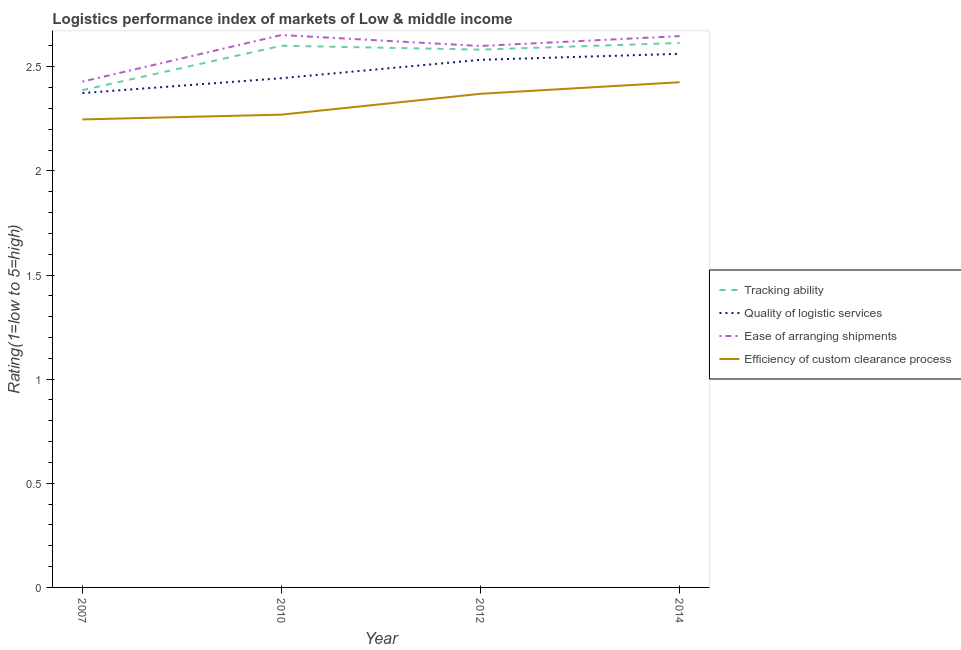Is the number of lines equal to the number of legend labels?
Provide a succinct answer. Yes. What is the lpi rating of efficiency of custom clearance process in 2007?
Provide a succinct answer. 2.25. Across all years, what is the maximum lpi rating of ease of arranging shipments?
Your response must be concise. 2.65. Across all years, what is the minimum lpi rating of quality of logistic services?
Ensure brevity in your answer.  2.37. In which year was the lpi rating of quality of logistic services maximum?
Your answer should be very brief. 2014. In which year was the lpi rating of efficiency of custom clearance process minimum?
Make the answer very short. 2007. What is the total lpi rating of tracking ability in the graph?
Your answer should be very brief. 10.19. What is the difference between the lpi rating of tracking ability in 2007 and that in 2010?
Your answer should be compact. -0.21. What is the difference between the lpi rating of tracking ability in 2012 and the lpi rating of quality of logistic services in 2007?
Provide a succinct answer. 0.21. What is the average lpi rating of efficiency of custom clearance process per year?
Ensure brevity in your answer.  2.33. In the year 2014, what is the difference between the lpi rating of quality of logistic services and lpi rating of efficiency of custom clearance process?
Offer a terse response. 0.14. What is the ratio of the lpi rating of quality of logistic services in 2010 to that in 2012?
Provide a succinct answer. 0.97. What is the difference between the highest and the second highest lpi rating of ease of arranging shipments?
Give a very brief answer. 0.01. What is the difference between the highest and the lowest lpi rating of ease of arranging shipments?
Keep it short and to the point. 0.22. Is the sum of the lpi rating of tracking ability in 2012 and 2014 greater than the maximum lpi rating of efficiency of custom clearance process across all years?
Make the answer very short. Yes. Is the lpi rating of ease of arranging shipments strictly greater than the lpi rating of tracking ability over the years?
Your answer should be compact. Yes. Are the values on the major ticks of Y-axis written in scientific E-notation?
Your answer should be very brief. No. Where does the legend appear in the graph?
Make the answer very short. Center right. What is the title of the graph?
Your answer should be compact. Logistics performance index of markets of Low & middle income. What is the label or title of the Y-axis?
Your answer should be compact. Rating(1=low to 5=high). What is the Rating(1=low to 5=high) of Tracking ability in 2007?
Keep it short and to the point. 2.39. What is the Rating(1=low to 5=high) in Quality of logistic services in 2007?
Your response must be concise. 2.37. What is the Rating(1=low to 5=high) in Ease of arranging shipments in 2007?
Provide a short and direct response. 2.43. What is the Rating(1=low to 5=high) in Efficiency of custom clearance process in 2007?
Offer a very short reply. 2.25. What is the Rating(1=low to 5=high) of Tracking ability in 2010?
Your answer should be very brief. 2.6. What is the Rating(1=low to 5=high) of Quality of logistic services in 2010?
Your answer should be compact. 2.45. What is the Rating(1=low to 5=high) of Ease of arranging shipments in 2010?
Provide a succinct answer. 2.65. What is the Rating(1=low to 5=high) of Efficiency of custom clearance process in 2010?
Ensure brevity in your answer.  2.27. What is the Rating(1=low to 5=high) in Tracking ability in 2012?
Give a very brief answer. 2.58. What is the Rating(1=low to 5=high) in Quality of logistic services in 2012?
Make the answer very short. 2.53. What is the Rating(1=low to 5=high) in Ease of arranging shipments in 2012?
Make the answer very short. 2.6. What is the Rating(1=low to 5=high) of Efficiency of custom clearance process in 2012?
Keep it short and to the point. 2.37. What is the Rating(1=low to 5=high) of Tracking ability in 2014?
Provide a short and direct response. 2.61. What is the Rating(1=low to 5=high) in Quality of logistic services in 2014?
Provide a succinct answer. 2.56. What is the Rating(1=low to 5=high) of Ease of arranging shipments in 2014?
Ensure brevity in your answer.  2.65. What is the Rating(1=low to 5=high) in Efficiency of custom clearance process in 2014?
Ensure brevity in your answer.  2.43. Across all years, what is the maximum Rating(1=low to 5=high) of Tracking ability?
Provide a short and direct response. 2.61. Across all years, what is the maximum Rating(1=low to 5=high) of Quality of logistic services?
Provide a short and direct response. 2.56. Across all years, what is the maximum Rating(1=low to 5=high) in Ease of arranging shipments?
Your response must be concise. 2.65. Across all years, what is the maximum Rating(1=low to 5=high) in Efficiency of custom clearance process?
Provide a short and direct response. 2.43. Across all years, what is the minimum Rating(1=low to 5=high) of Tracking ability?
Your response must be concise. 2.39. Across all years, what is the minimum Rating(1=low to 5=high) of Quality of logistic services?
Provide a succinct answer. 2.37. Across all years, what is the minimum Rating(1=low to 5=high) in Ease of arranging shipments?
Your response must be concise. 2.43. Across all years, what is the minimum Rating(1=low to 5=high) in Efficiency of custom clearance process?
Offer a very short reply. 2.25. What is the total Rating(1=low to 5=high) in Tracking ability in the graph?
Make the answer very short. 10.19. What is the total Rating(1=low to 5=high) of Quality of logistic services in the graph?
Offer a terse response. 9.91. What is the total Rating(1=low to 5=high) of Ease of arranging shipments in the graph?
Make the answer very short. 10.33. What is the total Rating(1=low to 5=high) of Efficiency of custom clearance process in the graph?
Your answer should be very brief. 9.31. What is the difference between the Rating(1=low to 5=high) of Tracking ability in 2007 and that in 2010?
Your answer should be compact. -0.21. What is the difference between the Rating(1=low to 5=high) of Quality of logistic services in 2007 and that in 2010?
Your answer should be compact. -0.07. What is the difference between the Rating(1=low to 5=high) of Ease of arranging shipments in 2007 and that in 2010?
Offer a very short reply. -0.22. What is the difference between the Rating(1=low to 5=high) in Efficiency of custom clearance process in 2007 and that in 2010?
Provide a short and direct response. -0.02. What is the difference between the Rating(1=low to 5=high) of Tracking ability in 2007 and that in 2012?
Give a very brief answer. -0.19. What is the difference between the Rating(1=low to 5=high) of Quality of logistic services in 2007 and that in 2012?
Offer a terse response. -0.16. What is the difference between the Rating(1=low to 5=high) in Ease of arranging shipments in 2007 and that in 2012?
Keep it short and to the point. -0.17. What is the difference between the Rating(1=low to 5=high) of Efficiency of custom clearance process in 2007 and that in 2012?
Provide a succinct answer. -0.12. What is the difference between the Rating(1=low to 5=high) in Tracking ability in 2007 and that in 2014?
Keep it short and to the point. -0.23. What is the difference between the Rating(1=low to 5=high) in Quality of logistic services in 2007 and that in 2014?
Provide a succinct answer. -0.19. What is the difference between the Rating(1=low to 5=high) of Ease of arranging shipments in 2007 and that in 2014?
Make the answer very short. -0.22. What is the difference between the Rating(1=low to 5=high) of Efficiency of custom clearance process in 2007 and that in 2014?
Your response must be concise. -0.18. What is the difference between the Rating(1=low to 5=high) in Tracking ability in 2010 and that in 2012?
Your response must be concise. 0.02. What is the difference between the Rating(1=low to 5=high) in Quality of logistic services in 2010 and that in 2012?
Provide a short and direct response. -0.09. What is the difference between the Rating(1=low to 5=high) of Ease of arranging shipments in 2010 and that in 2012?
Your answer should be very brief. 0.05. What is the difference between the Rating(1=low to 5=high) in Efficiency of custom clearance process in 2010 and that in 2012?
Provide a succinct answer. -0.1. What is the difference between the Rating(1=low to 5=high) in Tracking ability in 2010 and that in 2014?
Make the answer very short. -0.01. What is the difference between the Rating(1=low to 5=high) in Quality of logistic services in 2010 and that in 2014?
Your answer should be very brief. -0.12. What is the difference between the Rating(1=low to 5=high) of Ease of arranging shipments in 2010 and that in 2014?
Your response must be concise. 0.01. What is the difference between the Rating(1=low to 5=high) in Efficiency of custom clearance process in 2010 and that in 2014?
Offer a very short reply. -0.16. What is the difference between the Rating(1=low to 5=high) of Tracking ability in 2012 and that in 2014?
Offer a terse response. -0.03. What is the difference between the Rating(1=low to 5=high) in Quality of logistic services in 2012 and that in 2014?
Keep it short and to the point. -0.03. What is the difference between the Rating(1=low to 5=high) in Ease of arranging shipments in 2012 and that in 2014?
Give a very brief answer. -0.05. What is the difference between the Rating(1=low to 5=high) of Efficiency of custom clearance process in 2012 and that in 2014?
Your response must be concise. -0.06. What is the difference between the Rating(1=low to 5=high) in Tracking ability in 2007 and the Rating(1=low to 5=high) in Quality of logistic services in 2010?
Ensure brevity in your answer.  -0.06. What is the difference between the Rating(1=low to 5=high) of Tracking ability in 2007 and the Rating(1=low to 5=high) of Ease of arranging shipments in 2010?
Offer a very short reply. -0.26. What is the difference between the Rating(1=low to 5=high) of Tracking ability in 2007 and the Rating(1=low to 5=high) of Efficiency of custom clearance process in 2010?
Give a very brief answer. 0.12. What is the difference between the Rating(1=low to 5=high) of Quality of logistic services in 2007 and the Rating(1=low to 5=high) of Ease of arranging shipments in 2010?
Provide a succinct answer. -0.28. What is the difference between the Rating(1=low to 5=high) in Quality of logistic services in 2007 and the Rating(1=low to 5=high) in Efficiency of custom clearance process in 2010?
Give a very brief answer. 0.1. What is the difference between the Rating(1=low to 5=high) in Ease of arranging shipments in 2007 and the Rating(1=low to 5=high) in Efficiency of custom clearance process in 2010?
Provide a succinct answer. 0.16. What is the difference between the Rating(1=low to 5=high) of Tracking ability in 2007 and the Rating(1=low to 5=high) of Quality of logistic services in 2012?
Give a very brief answer. -0.15. What is the difference between the Rating(1=low to 5=high) in Tracking ability in 2007 and the Rating(1=low to 5=high) in Ease of arranging shipments in 2012?
Give a very brief answer. -0.21. What is the difference between the Rating(1=low to 5=high) of Tracking ability in 2007 and the Rating(1=low to 5=high) of Efficiency of custom clearance process in 2012?
Ensure brevity in your answer.  0.02. What is the difference between the Rating(1=low to 5=high) of Quality of logistic services in 2007 and the Rating(1=low to 5=high) of Ease of arranging shipments in 2012?
Provide a short and direct response. -0.23. What is the difference between the Rating(1=low to 5=high) in Quality of logistic services in 2007 and the Rating(1=low to 5=high) in Efficiency of custom clearance process in 2012?
Provide a short and direct response. 0. What is the difference between the Rating(1=low to 5=high) in Ease of arranging shipments in 2007 and the Rating(1=low to 5=high) in Efficiency of custom clearance process in 2012?
Provide a short and direct response. 0.06. What is the difference between the Rating(1=low to 5=high) of Tracking ability in 2007 and the Rating(1=low to 5=high) of Quality of logistic services in 2014?
Keep it short and to the point. -0.17. What is the difference between the Rating(1=low to 5=high) in Tracking ability in 2007 and the Rating(1=low to 5=high) in Ease of arranging shipments in 2014?
Keep it short and to the point. -0.26. What is the difference between the Rating(1=low to 5=high) in Tracking ability in 2007 and the Rating(1=low to 5=high) in Efficiency of custom clearance process in 2014?
Provide a short and direct response. -0.04. What is the difference between the Rating(1=low to 5=high) of Quality of logistic services in 2007 and the Rating(1=low to 5=high) of Ease of arranging shipments in 2014?
Your response must be concise. -0.27. What is the difference between the Rating(1=low to 5=high) of Quality of logistic services in 2007 and the Rating(1=low to 5=high) of Efficiency of custom clearance process in 2014?
Provide a succinct answer. -0.05. What is the difference between the Rating(1=low to 5=high) in Ease of arranging shipments in 2007 and the Rating(1=low to 5=high) in Efficiency of custom clearance process in 2014?
Provide a short and direct response. 0. What is the difference between the Rating(1=low to 5=high) in Tracking ability in 2010 and the Rating(1=low to 5=high) in Quality of logistic services in 2012?
Ensure brevity in your answer.  0.07. What is the difference between the Rating(1=low to 5=high) in Tracking ability in 2010 and the Rating(1=low to 5=high) in Ease of arranging shipments in 2012?
Ensure brevity in your answer.  0. What is the difference between the Rating(1=low to 5=high) of Tracking ability in 2010 and the Rating(1=low to 5=high) of Efficiency of custom clearance process in 2012?
Offer a very short reply. 0.23. What is the difference between the Rating(1=low to 5=high) of Quality of logistic services in 2010 and the Rating(1=low to 5=high) of Ease of arranging shipments in 2012?
Keep it short and to the point. -0.15. What is the difference between the Rating(1=low to 5=high) in Quality of logistic services in 2010 and the Rating(1=low to 5=high) in Efficiency of custom clearance process in 2012?
Give a very brief answer. 0.07. What is the difference between the Rating(1=low to 5=high) in Ease of arranging shipments in 2010 and the Rating(1=low to 5=high) in Efficiency of custom clearance process in 2012?
Your answer should be compact. 0.28. What is the difference between the Rating(1=low to 5=high) of Tracking ability in 2010 and the Rating(1=low to 5=high) of Quality of logistic services in 2014?
Give a very brief answer. 0.04. What is the difference between the Rating(1=low to 5=high) of Tracking ability in 2010 and the Rating(1=low to 5=high) of Ease of arranging shipments in 2014?
Your answer should be compact. -0.05. What is the difference between the Rating(1=low to 5=high) of Tracking ability in 2010 and the Rating(1=low to 5=high) of Efficiency of custom clearance process in 2014?
Your answer should be compact. 0.18. What is the difference between the Rating(1=low to 5=high) of Quality of logistic services in 2010 and the Rating(1=low to 5=high) of Ease of arranging shipments in 2014?
Make the answer very short. -0.2. What is the difference between the Rating(1=low to 5=high) of Quality of logistic services in 2010 and the Rating(1=low to 5=high) of Efficiency of custom clearance process in 2014?
Your answer should be compact. 0.02. What is the difference between the Rating(1=low to 5=high) of Ease of arranging shipments in 2010 and the Rating(1=low to 5=high) of Efficiency of custom clearance process in 2014?
Provide a short and direct response. 0.23. What is the difference between the Rating(1=low to 5=high) of Tracking ability in 2012 and the Rating(1=low to 5=high) of Quality of logistic services in 2014?
Offer a terse response. 0.02. What is the difference between the Rating(1=low to 5=high) of Tracking ability in 2012 and the Rating(1=low to 5=high) of Ease of arranging shipments in 2014?
Your answer should be very brief. -0.06. What is the difference between the Rating(1=low to 5=high) of Tracking ability in 2012 and the Rating(1=low to 5=high) of Efficiency of custom clearance process in 2014?
Make the answer very short. 0.16. What is the difference between the Rating(1=low to 5=high) in Quality of logistic services in 2012 and the Rating(1=low to 5=high) in Ease of arranging shipments in 2014?
Your answer should be very brief. -0.11. What is the difference between the Rating(1=low to 5=high) of Quality of logistic services in 2012 and the Rating(1=low to 5=high) of Efficiency of custom clearance process in 2014?
Your response must be concise. 0.11. What is the difference between the Rating(1=low to 5=high) in Ease of arranging shipments in 2012 and the Rating(1=low to 5=high) in Efficiency of custom clearance process in 2014?
Provide a succinct answer. 0.17. What is the average Rating(1=low to 5=high) in Tracking ability per year?
Offer a very short reply. 2.55. What is the average Rating(1=low to 5=high) of Quality of logistic services per year?
Provide a short and direct response. 2.48. What is the average Rating(1=low to 5=high) of Ease of arranging shipments per year?
Offer a very short reply. 2.58. What is the average Rating(1=low to 5=high) of Efficiency of custom clearance process per year?
Offer a very short reply. 2.33. In the year 2007, what is the difference between the Rating(1=low to 5=high) in Tracking ability and Rating(1=low to 5=high) in Quality of logistic services?
Provide a succinct answer. 0.01. In the year 2007, what is the difference between the Rating(1=low to 5=high) in Tracking ability and Rating(1=low to 5=high) in Ease of arranging shipments?
Offer a terse response. -0.04. In the year 2007, what is the difference between the Rating(1=low to 5=high) of Tracking ability and Rating(1=low to 5=high) of Efficiency of custom clearance process?
Your answer should be compact. 0.14. In the year 2007, what is the difference between the Rating(1=low to 5=high) of Quality of logistic services and Rating(1=low to 5=high) of Ease of arranging shipments?
Ensure brevity in your answer.  -0.05. In the year 2007, what is the difference between the Rating(1=low to 5=high) in Quality of logistic services and Rating(1=low to 5=high) in Efficiency of custom clearance process?
Make the answer very short. 0.13. In the year 2007, what is the difference between the Rating(1=low to 5=high) of Ease of arranging shipments and Rating(1=low to 5=high) of Efficiency of custom clearance process?
Keep it short and to the point. 0.18. In the year 2010, what is the difference between the Rating(1=low to 5=high) of Tracking ability and Rating(1=low to 5=high) of Quality of logistic services?
Offer a terse response. 0.16. In the year 2010, what is the difference between the Rating(1=low to 5=high) in Tracking ability and Rating(1=low to 5=high) in Ease of arranging shipments?
Offer a terse response. -0.05. In the year 2010, what is the difference between the Rating(1=low to 5=high) in Tracking ability and Rating(1=low to 5=high) in Efficiency of custom clearance process?
Keep it short and to the point. 0.33. In the year 2010, what is the difference between the Rating(1=low to 5=high) of Quality of logistic services and Rating(1=low to 5=high) of Ease of arranging shipments?
Your answer should be compact. -0.21. In the year 2010, what is the difference between the Rating(1=low to 5=high) of Quality of logistic services and Rating(1=low to 5=high) of Efficiency of custom clearance process?
Make the answer very short. 0.17. In the year 2010, what is the difference between the Rating(1=low to 5=high) in Ease of arranging shipments and Rating(1=low to 5=high) in Efficiency of custom clearance process?
Keep it short and to the point. 0.38. In the year 2012, what is the difference between the Rating(1=low to 5=high) of Tracking ability and Rating(1=low to 5=high) of Quality of logistic services?
Provide a short and direct response. 0.05. In the year 2012, what is the difference between the Rating(1=low to 5=high) of Tracking ability and Rating(1=low to 5=high) of Ease of arranging shipments?
Offer a terse response. -0.02. In the year 2012, what is the difference between the Rating(1=low to 5=high) of Tracking ability and Rating(1=low to 5=high) of Efficiency of custom clearance process?
Your answer should be compact. 0.21. In the year 2012, what is the difference between the Rating(1=low to 5=high) in Quality of logistic services and Rating(1=low to 5=high) in Ease of arranging shipments?
Your response must be concise. -0.07. In the year 2012, what is the difference between the Rating(1=low to 5=high) of Quality of logistic services and Rating(1=low to 5=high) of Efficiency of custom clearance process?
Your answer should be compact. 0.16. In the year 2012, what is the difference between the Rating(1=low to 5=high) in Ease of arranging shipments and Rating(1=low to 5=high) in Efficiency of custom clearance process?
Offer a terse response. 0.23. In the year 2014, what is the difference between the Rating(1=low to 5=high) of Tracking ability and Rating(1=low to 5=high) of Quality of logistic services?
Offer a terse response. 0.05. In the year 2014, what is the difference between the Rating(1=low to 5=high) of Tracking ability and Rating(1=low to 5=high) of Ease of arranging shipments?
Provide a short and direct response. -0.03. In the year 2014, what is the difference between the Rating(1=low to 5=high) of Tracking ability and Rating(1=low to 5=high) of Efficiency of custom clearance process?
Keep it short and to the point. 0.19. In the year 2014, what is the difference between the Rating(1=low to 5=high) of Quality of logistic services and Rating(1=low to 5=high) of Ease of arranging shipments?
Offer a terse response. -0.09. In the year 2014, what is the difference between the Rating(1=low to 5=high) in Quality of logistic services and Rating(1=low to 5=high) in Efficiency of custom clearance process?
Offer a very short reply. 0.14. In the year 2014, what is the difference between the Rating(1=low to 5=high) in Ease of arranging shipments and Rating(1=low to 5=high) in Efficiency of custom clearance process?
Keep it short and to the point. 0.22. What is the ratio of the Rating(1=low to 5=high) of Tracking ability in 2007 to that in 2010?
Ensure brevity in your answer.  0.92. What is the ratio of the Rating(1=low to 5=high) in Quality of logistic services in 2007 to that in 2010?
Ensure brevity in your answer.  0.97. What is the ratio of the Rating(1=low to 5=high) of Ease of arranging shipments in 2007 to that in 2010?
Your response must be concise. 0.92. What is the ratio of the Rating(1=low to 5=high) of Tracking ability in 2007 to that in 2012?
Your answer should be very brief. 0.92. What is the ratio of the Rating(1=low to 5=high) of Quality of logistic services in 2007 to that in 2012?
Offer a very short reply. 0.94. What is the ratio of the Rating(1=low to 5=high) of Ease of arranging shipments in 2007 to that in 2012?
Offer a very short reply. 0.93. What is the ratio of the Rating(1=low to 5=high) in Efficiency of custom clearance process in 2007 to that in 2012?
Your response must be concise. 0.95. What is the ratio of the Rating(1=low to 5=high) in Tracking ability in 2007 to that in 2014?
Keep it short and to the point. 0.91. What is the ratio of the Rating(1=low to 5=high) in Quality of logistic services in 2007 to that in 2014?
Provide a succinct answer. 0.93. What is the ratio of the Rating(1=low to 5=high) in Ease of arranging shipments in 2007 to that in 2014?
Give a very brief answer. 0.92. What is the ratio of the Rating(1=low to 5=high) of Efficiency of custom clearance process in 2007 to that in 2014?
Offer a terse response. 0.93. What is the ratio of the Rating(1=low to 5=high) in Tracking ability in 2010 to that in 2012?
Offer a very short reply. 1.01. What is the ratio of the Rating(1=low to 5=high) in Quality of logistic services in 2010 to that in 2012?
Provide a succinct answer. 0.97. What is the ratio of the Rating(1=low to 5=high) in Ease of arranging shipments in 2010 to that in 2012?
Make the answer very short. 1.02. What is the ratio of the Rating(1=low to 5=high) in Efficiency of custom clearance process in 2010 to that in 2012?
Provide a short and direct response. 0.96. What is the ratio of the Rating(1=low to 5=high) of Tracking ability in 2010 to that in 2014?
Provide a short and direct response. 0.99. What is the ratio of the Rating(1=low to 5=high) of Quality of logistic services in 2010 to that in 2014?
Your response must be concise. 0.95. What is the ratio of the Rating(1=low to 5=high) of Efficiency of custom clearance process in 2010 to that in 2014?
Your response must be concise. 0.94. What is the ratio of the Rating(1=low to 5=high) in Ease of arranging shipments in 2012 to that in 2014?
Offer a terse response. 0.98. What is the ratio of the Rating(1=low to 5=high) of Efficiency of custom clearance process in 2012 to that in 2014?
Keep it short and to the point. 0.98. What is the difference between the highest and the second highest Rating(1=low to 5=high) of Tracking ability?
Your response must be concise. 0.01. What is the difference between the highest and the second highest Rating(1=low to 5=high) in Quality of logistic services?
Make the answer very short. 0.03. What is the difference between the highest and the second highest Rating(1=low to 5=high) of Ease of arranging shipments?
Give a very brief answer. 0.01. What is the difference between the highest and the second highest Rating(1=low to 5=high) of Efficiency of custom clearance process?
Give a very brief answer. 0.06. What is the difference between the highest and the lowest Rating(1=low to 5=high) of Tracking ability?
Your answer should be very brief. 0.23. What is the difference between the highest and the lowest Rating(1=low to 5=high) in Quality of logistic services?
Provide a short and direct response. 0.19. What is the difference between the highest and the lowest Rating(1=low to 5=high) of Ease of arranging shipments?
Ensure brevity in your answer.  0.22. What is the difference between the highest and the lowest Rating(1=low to 5=high) of Efficiency of custom clearance process?
Provide a short and direct response. 0.18. 